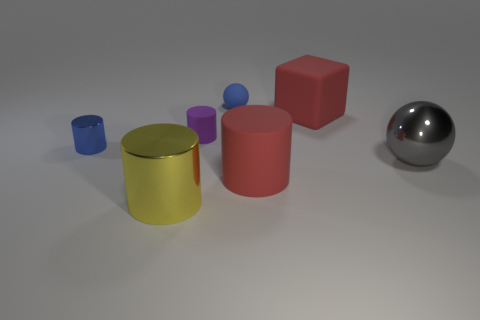What is the shape of the large rubber thing that is the same color as the matte cube?
Provide a succinct answer. Cylinder. There is a large red object right of the matte cylinder on the right side of the rubber cylinder that is behind the small blue metal cylinder; what is it made of?
Give a very brief answer. Rubber. There is a red matte cylinder; is its size the same as the blue object right of the purple thing?
Ensure brevity in your answer.  No. There is a gray thing that is the same shape as the small blue matte thing; what is it made of?
Give a very brief answer. Metal. There is a blue object that is right of the cylinder that is behind the metallic object behind the large gray sphere; what is its size?
Offer a terse response. Small. Is the size of the gray metallic object the same as the red rubber cylinder?
Provide a short and direct response. Yes. There is a ball that is left of the red matte object in front of the blue metal object; what is its material?
Provide a short and direct response. Rubber. Is the shape of the metal object to the right of the large block the same as the small blue object behind the tiny matte cylinder?
Offer a very short reply. Yes. Are there an equal number of rubber spheres on the right side of the block and blue rubber cylinders?
Your response must be concise. Yes. There is a small ball that is behind the purple matte object; is there a yellow thing on the right side of it?
Provide a short and direct response. No. 